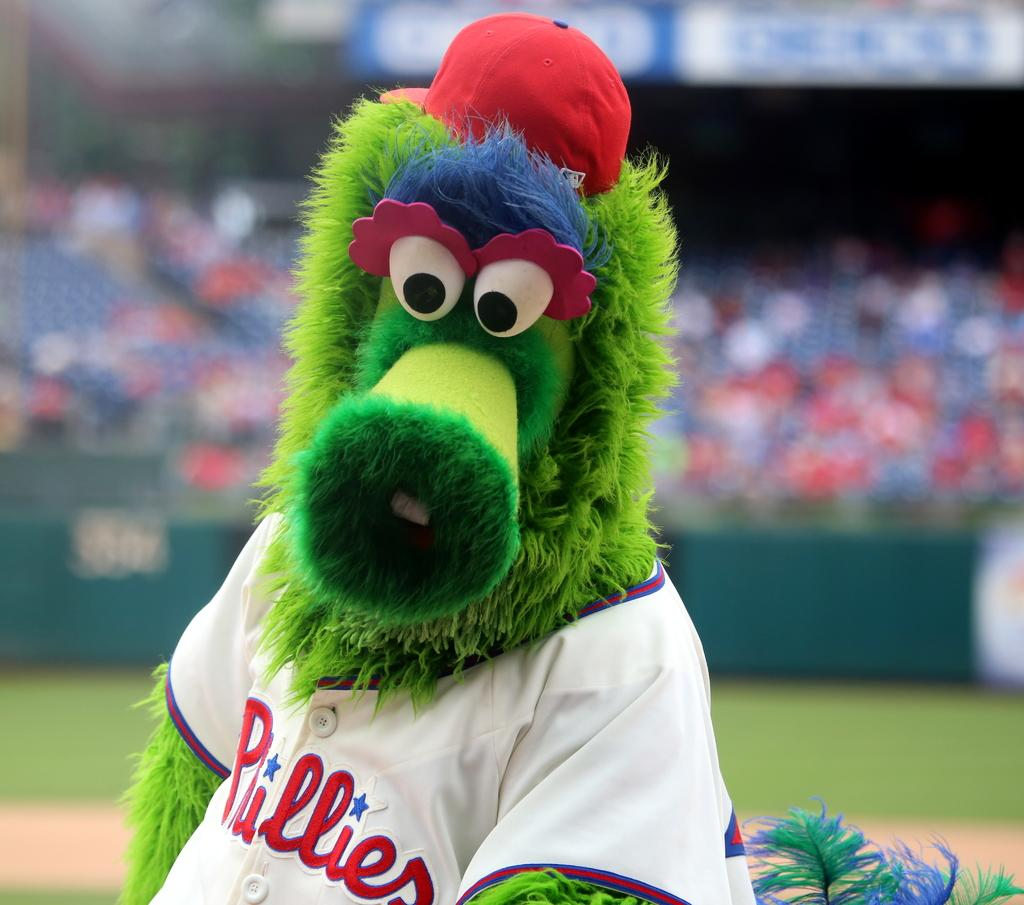Provide a one-sentence caption for the provided image. A sports mascot with a green fuzzy face and a tee shirt reading pullers. 